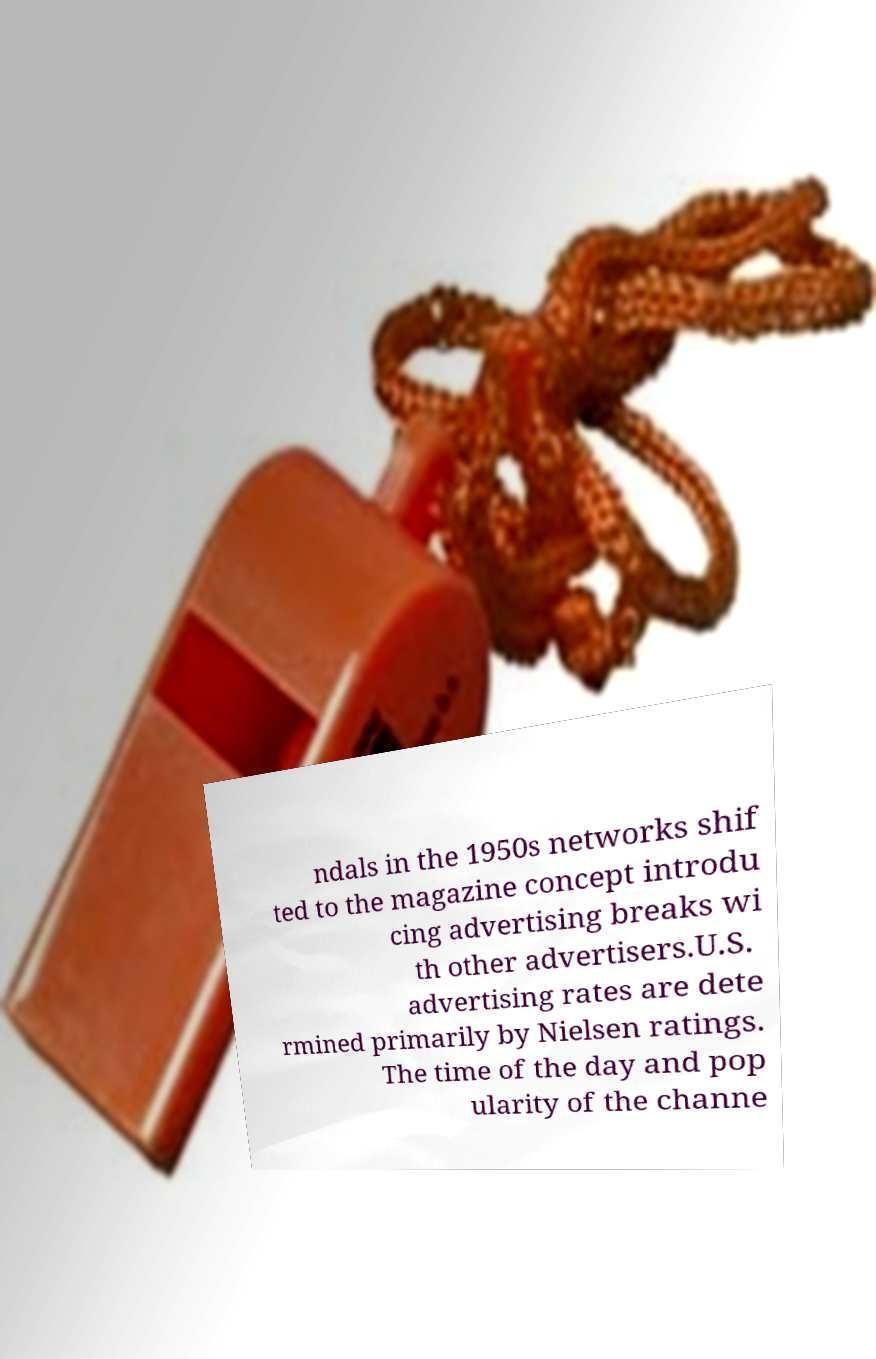Can you accurately transcribe the text from the provided image for me? ndals in the 1950s networks shif ted to the magazine concept introdu cing advertising breaks wi th other advertisers.U.S. advertising rates are dete rmined primarily by Nielsen ratings. The time of the day and pop ularity of the channe 